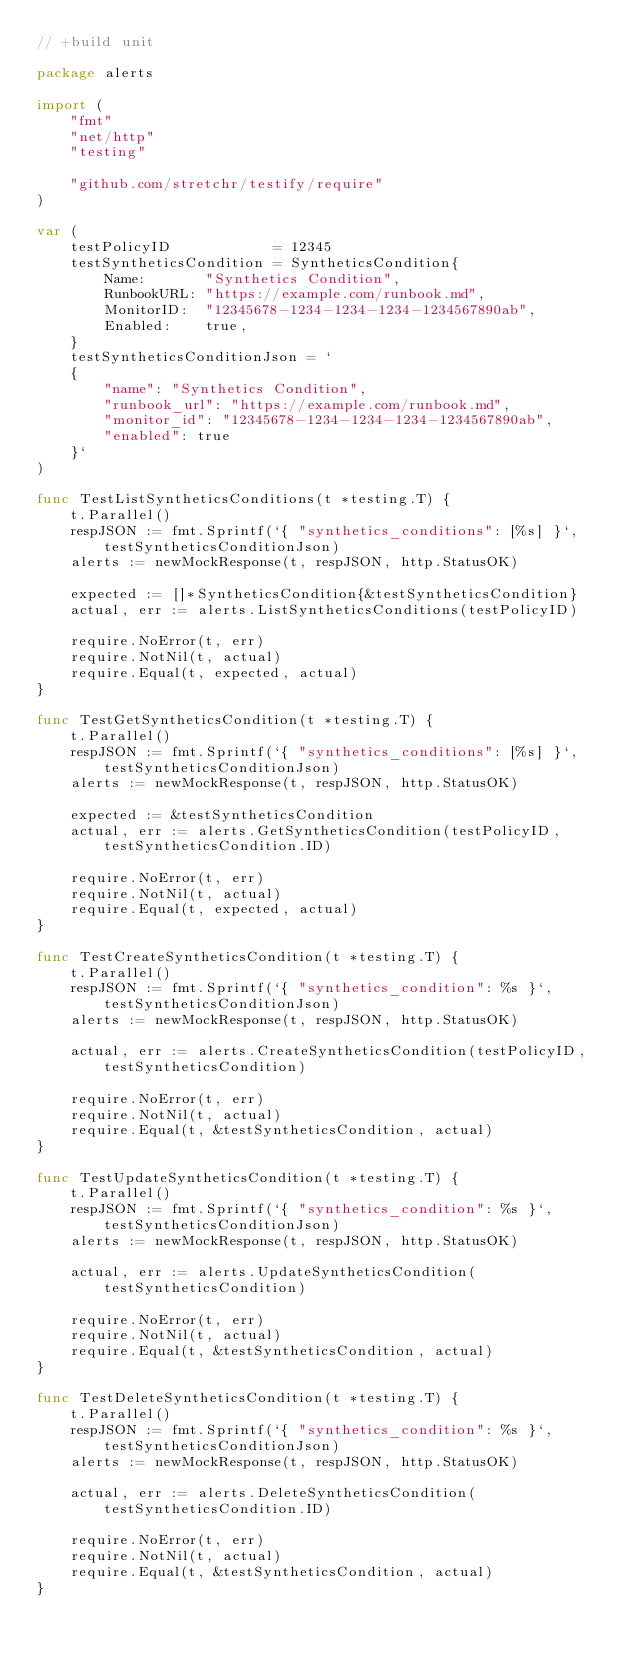<code> <loc_0><loc_0><loc_500><loc_500><_Go_>// +build unit

package alerts

import (
	"fmt"
	"net/http"
	"testing"

	"github.com/stretchr/testify/require"
)

var (
	testPolicyID            = 12345
	testSyntheticsCondition = SyntheticsCondition{
		Name:       "Synthetics Condition",
		RunbookURL: "https://example.com/runbook.md",
		MonitorID:  "12345678-1234-1234-1234-1234567890ab",
		Enabled:    true,
	}
	testSyntheticsConditionJson = `
	{
		"name": "Synthetics Condition",
		"runbook_url": "https://example.com/runbook.md",
		"monitor_id": "12345678-1234-1234-1234-1234567890ab",
		"enabled": true
	}`
)

func TestListSyntheticsConditions(t *testing.T) {
	t.Parallel()
	respJSON := fmt.Sprintf(`{ "synthetics_conditions": [%s] }`, testSyntheticsConditionJson)
	alerts := newMockResponse(t, respJSON, http.StatusOK)

	expected := []*SyntheticsCondition{&testSyntheticsCondition}
	actual, err := alerts.ListSyntheticsConditions(testPolicyID)

	require.NoError(t, err)
	require.NotNil(t, actual)
	require.Equal(t, expected, actual)
}

func TestGetSyntheticsCondition(t *testing.T) {
	t.Parallel()
	respJSON := fmt.Sprintf(`{ "synthetics_conditions": [%s] }`, testSyntheticsConditionJson)
	alerts := newMockResponse(t, respJSON, http.StatusOK)

	expected := &testSyntheticsCondition
	actual, err := alerts.GetSyntheticsCondition(testPolicyID, testSyntheticsCondition.ID)

	require.NoError(t, err)
	require.NotNil(t, actual)
	require.Equal(t, expected, actual)
}

func TestCreateSyntheticsCondition(t *testing.T) {
	t.Parallel()
	respJSON := fmt.Sprintf(`{ "synthetics_condition": %s }`, testSyntheticsConditionJson)
	alerts := newMockResponse(t, respJSON, http.StatusOK)

	actual, err := alerts.CreateSyntheticsCondition(testPolicyID, testSyntheticsCondition)

	require.NoError(t, err)
	require.NotNil(t, actual)
	require.Equal(t, &testSyntheticsCondition, actual)
}

func TestUpdateSyntheticsCondition(t *testing.T) {
	t.Parallel()
	respJSON := fmt.Sprintf(`{ "synthetics_condition": %s }`, testSyntheticsConditionJson)
	alerts := newMockResponse(t, respJSON, http.StatusOK)

	actual, err := alerts.UpdateSyntheticsCondition(testSyntheticsCondition)

	require.NoError(t, err)
	require.NotNil(t, actual)
	require.Equal(t, &testSyntheticsCondition, actual)
}

func TestDeleteSyntheticsCondition(t *testing.T) {
	t.Parallel()
	respJSON := fmt.Sprintf(`{ "synthetics_condition": %s }`, testSyntheticsConditionJson)
	alerts := newMockResponse(t, respJSON, http.StatusOK)

	actual, err := alerts.DeleteSyntheticsCondition(testSyntheticsCondition.ID)

	require.NoError(t, err)
	require.NotNil(t, actual)
	require.Equal(t, &testSyntheticsCondition, actual)
}
</code> 